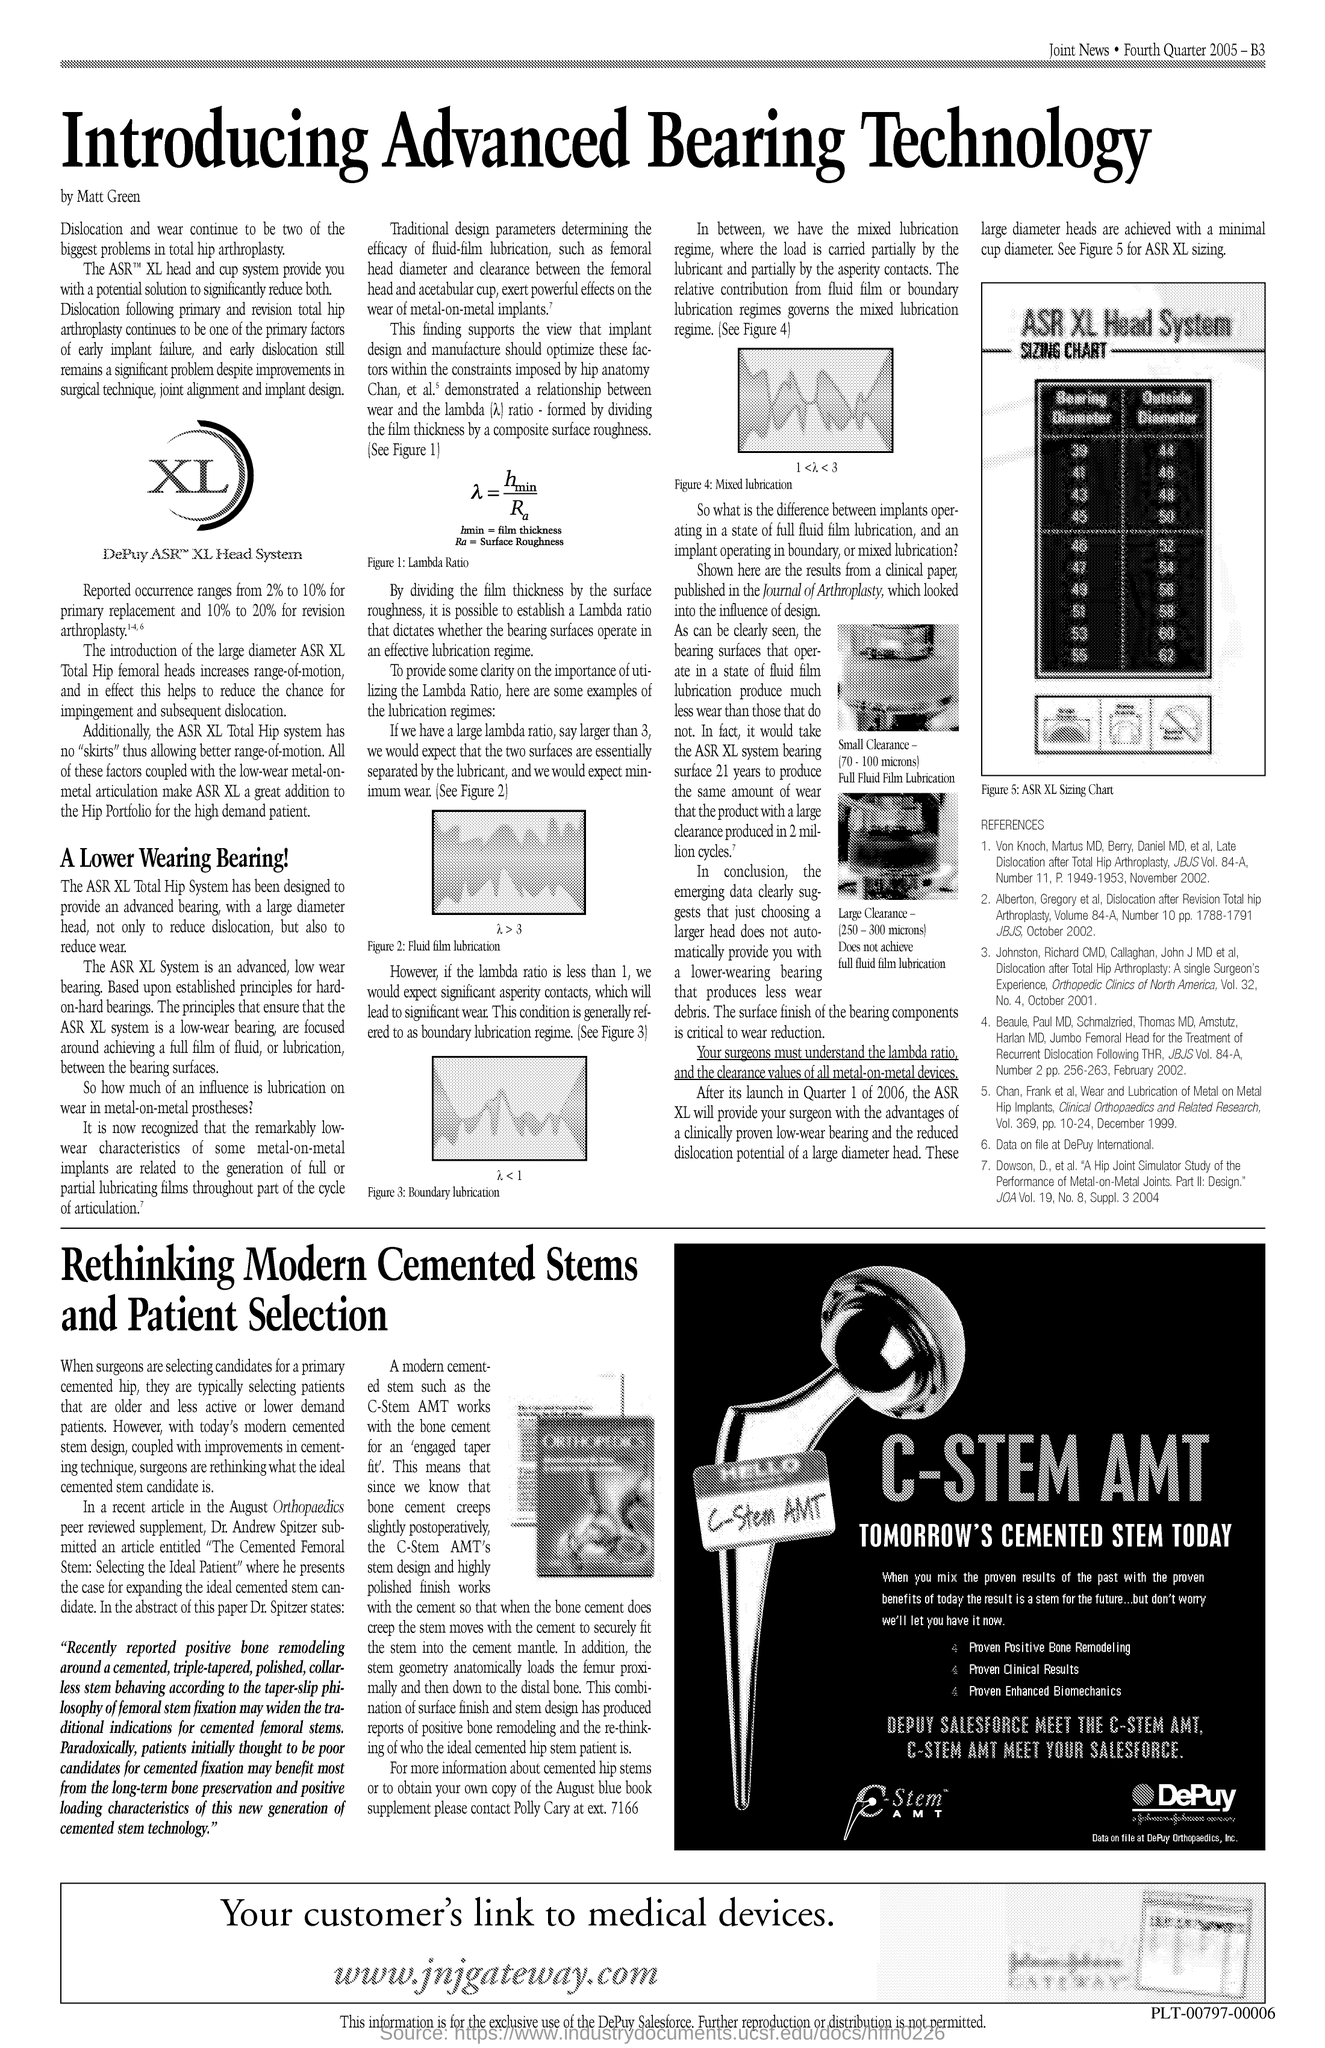What is the title of the document?
Your answer should be compact. Introducing Advanced Bearing Technology. 